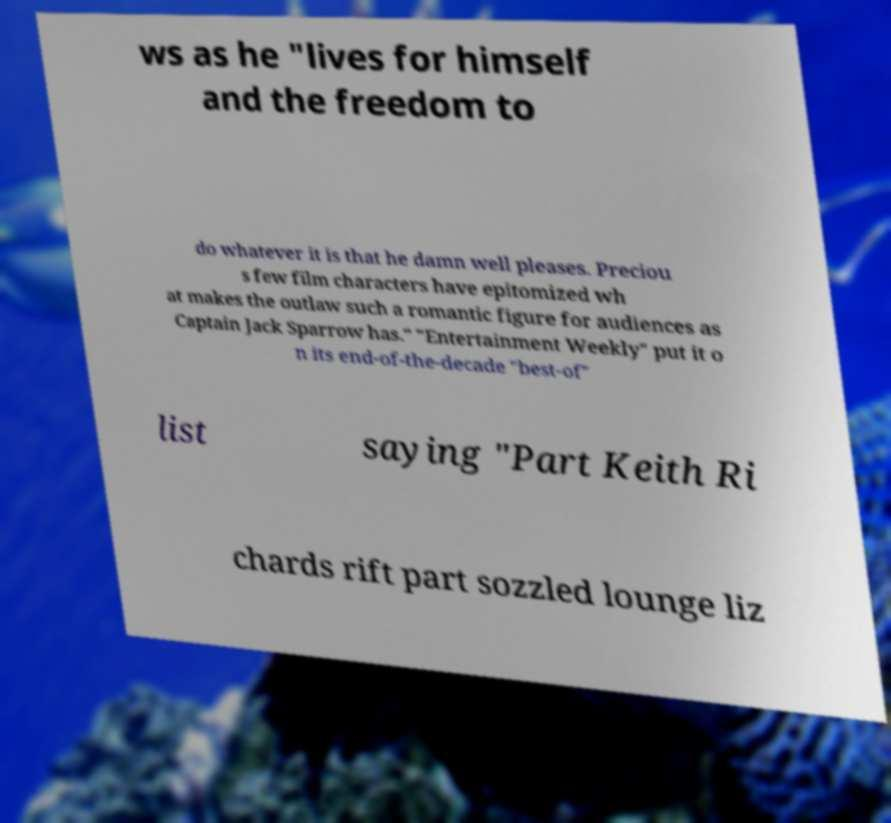There's text embedded in this image that I need extracted. Can you transcribe it verbatim? ws as he "lives for himself and the freedom to do whatever it is that he damn well pleases. Preciou s few film characters have epitomized wh at makes the outlaw such a romantic figure for audiences as Captain Jack Sparrow has." "Entertainment Weekly" put it o n its end-of-the-decade "best-of" list saying "Part Keith Ri chards rift part sozzled lounge liz 